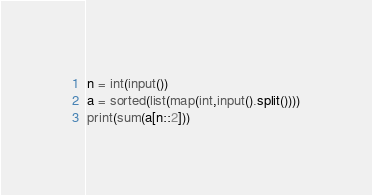Convert code to text. <code><loc_0><loc_0><loc_500><loc_500><_Python_>n = int(input())
a = sorted(list(map(int,input().split())))
print(sum(a[n::2]))</code> 